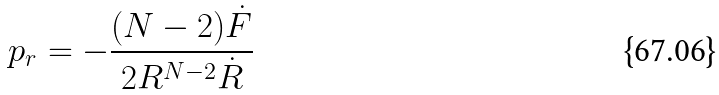Convert formula to latex. <formula><loc_0><loc_0><loc_500><loc_500>p _ { r } = - \frac { ( N - 2 ) \dot { F } } { 2 R ^ { N - 2 } \dot { R } }</formula> 